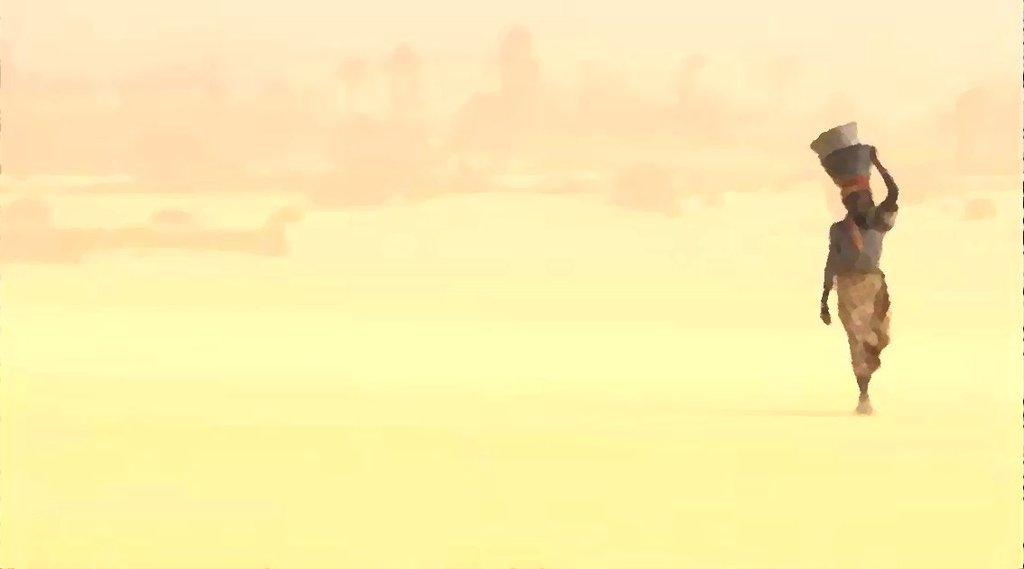What is the main subject in the foreground of the image? There is a woman in the foreground of the image. What is the woman doing in the image? The woman is walking in the image. What is unique about the way the woman is carrying objects? The woman is carrying objects on her head in the image. What color is the background of the image? The background of the image is yellow in color. What type of process is being carried out in the frame of the image? There is no specific process being carried out in the image; it simply shows a woman walking while carrying objects on her head. Can you see any tanks in the image? There are no tanks present in the image. 